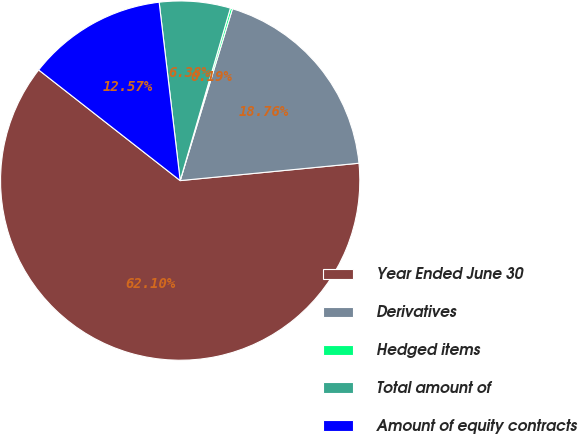Convert chart. <chart><loc_0><loc_0><loc_500><loc_500><pie_chart><fcel>Year Ended June 30<fcel>Derivatives<fcel>Hedged items<fcel>Total amount of<fcel>Amount of equity contracts<nl><fcel>62.11%<fcel>18.76%<fcel>0.19%<fcel>6.38%<fcel>12.57%<nl></chart> 